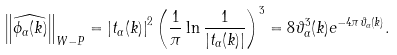Convert formula to latex. <formula><loc_0><loc_0><loc_500><loc_500>\left \| \widehat { \phi _ { \alpha } ( k ) } \right \| _ { W - P } = \left | t _ { \alpha } ( k ) \right | ^ { 2 } \left ( \frac { 1 } { \pi } \ln \frac { 1 } { | t _ { \alpha } ( k ) | } \right ) ^ { 3 } = 8 \vartheta _ { \alpha } ^ { 3 } ( k ) e ^ { - 4 \pi \vartheta _ { \alpha } ( k ) } .</formula> 